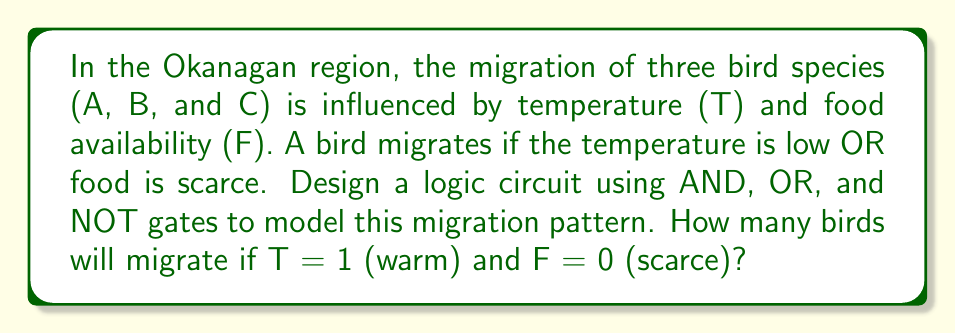Give your solution to this math problem. Let's approach this step-by-step:

1) First, we need to understand the logic:
   - A bird migrates if T is low (0) OR F is scarce (0)
   - This can be represented as: Migrate = NOT(T) OR NOT(F)

2) Let's design the circuit:
   a) We need two NOT gates for T and F
   b) We need one OR gate to combine the results

3) The circuit can be represented as:

   [asy]
   import geometry;

   // Define points
   pair A = (0,0), B = (50,0), C = (100,0), D = (150,0);
   pair E = (75,50), F = (125,50), G = (175,50);

   // Draw NOT gates
   draw(A--B--C--cycle);
   draw((B.x,B.y-5)--(B.x,B.y+5));
   label("T", A, W);
   
   draw(D--E--F--cycle);
   draw((E.x,E.y-5)--(E.x,E.y+5));
   label("F", D, W);

   // Draw OR gate
   path p = (125,25)..(150,50)..(175,25)--cycle;
   draw(p);
   draw((125,75)--(125,25));
   
   // Draw connections
   draw(C--G);
   draw(F--G);
   
   label("Migrate", (200,50), E);
   [/asy]

4) Now, let's evaluate for T = 1 and F = 0:
   - NOT(T) = 0
   - NOT(F) = 1
   - 0 OR 1 = 1

5) The output is 1, which means the birds will migrate.

6) Since this applies to all three bird species (A, B, and C), all three will migrate.
Answer: 3 birds 